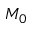<formula> <loc_0><loc_0><loc_500><loc_500>M _ { 0 }</formula> 